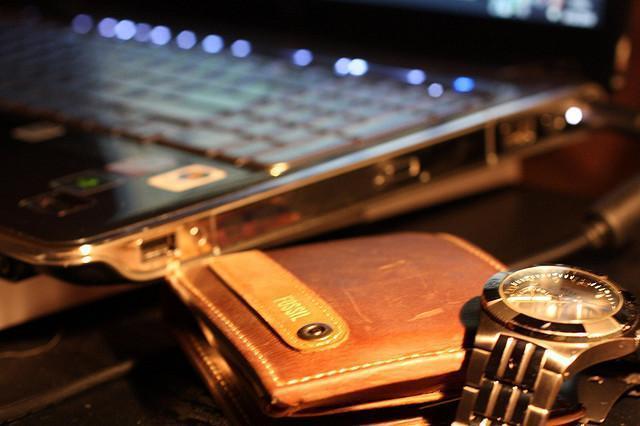How many coca-cola bottles are there?
Give a very brief answer. 0. 